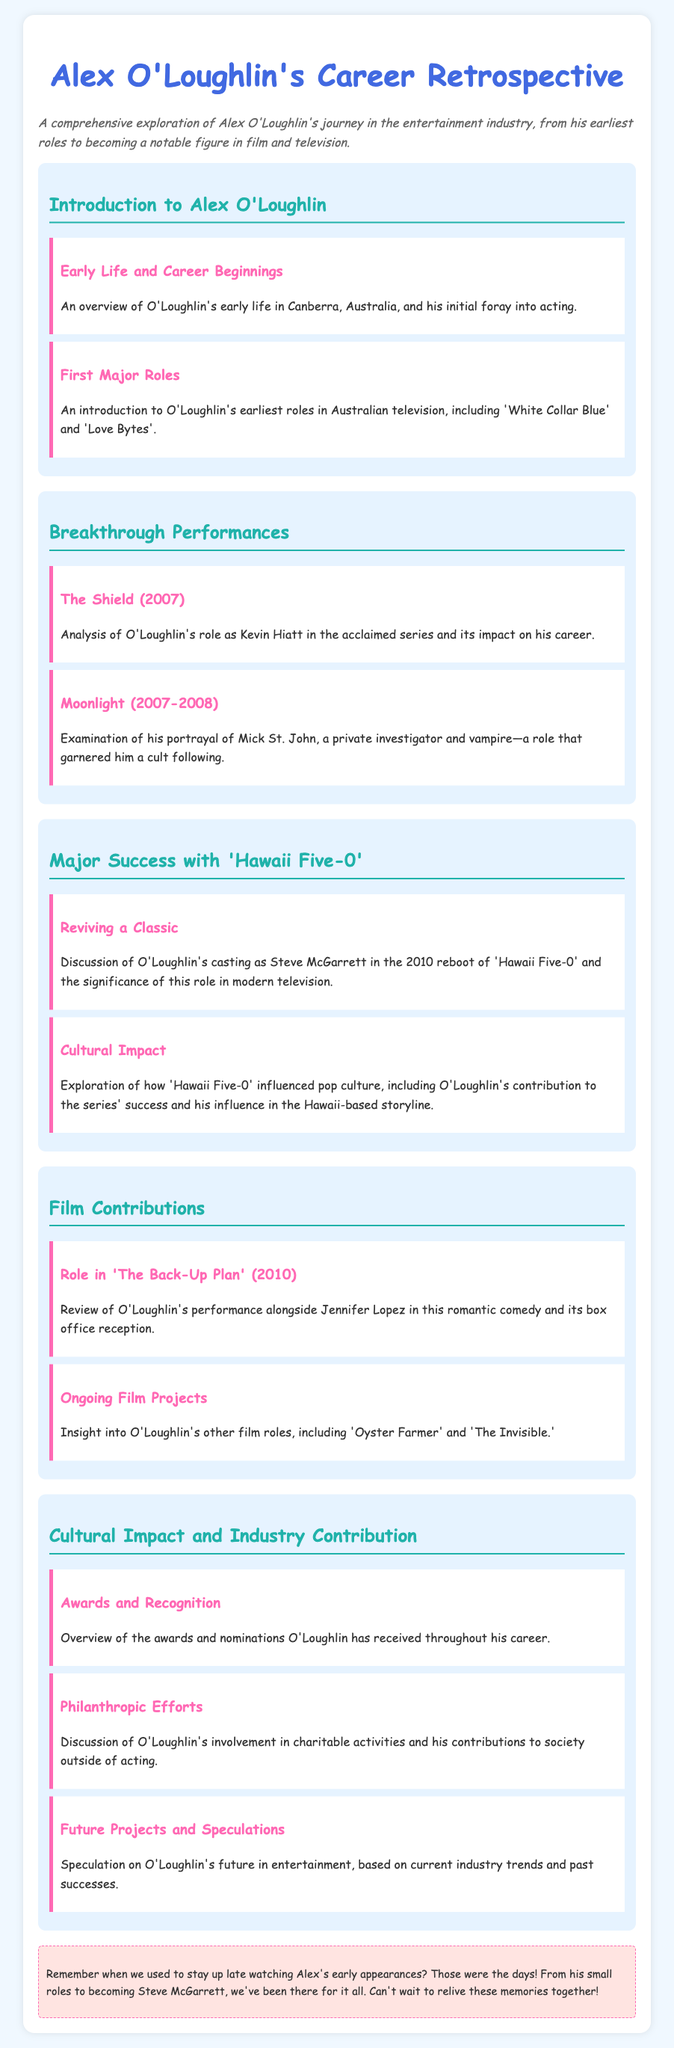What is Alex O'Loughlin's first major role? The document mentions 'White Collar Blue' as one of O'Loughlin's earliest roles in Australian television.
Answer: 'White Collar Blue' What year did 'Hawaii Five-0' reboot premiere? The document states that the reboot of 'Hawaii Five-0' was in 2010.
Answer: 2010 What character did Alex O'Loughlin portray in 'Moonlight'? The document specifies that O'Loughlin portrayed Mick St. John in 'Moonlight'.
Answer: Mick St. John What type of contributions does the document discuss regarding Alex O'Loughlin's career? The document discusses philanthropic efforts and contributions to society outside of acting.
Answer: Philanthropic efforts In which film did Alex O'Loughlin star alongside Jennifer Lopez? The document indicates his performance alongside Jennifer Lopez in 'The Back-Up Plan'.
Answer: The Back-Up Plan What was the impact of 'The Shield' on O'Loughlin's career? The document notes that his role as Kevin Hiatt in 'The Shield' had a significant impact on his career.
Answer: Significant impact What genre is 'The Back-Up Plan'? The document categorizes 'The Back-Up Plan' as a romantic comedy.
Answer: Romantic comedy What is one aspect of O'Loughlin's future mentioned in the syllabus? The document includes speculation on O'Loughlin's future projects based on industry trends.
Answer: Future projects 